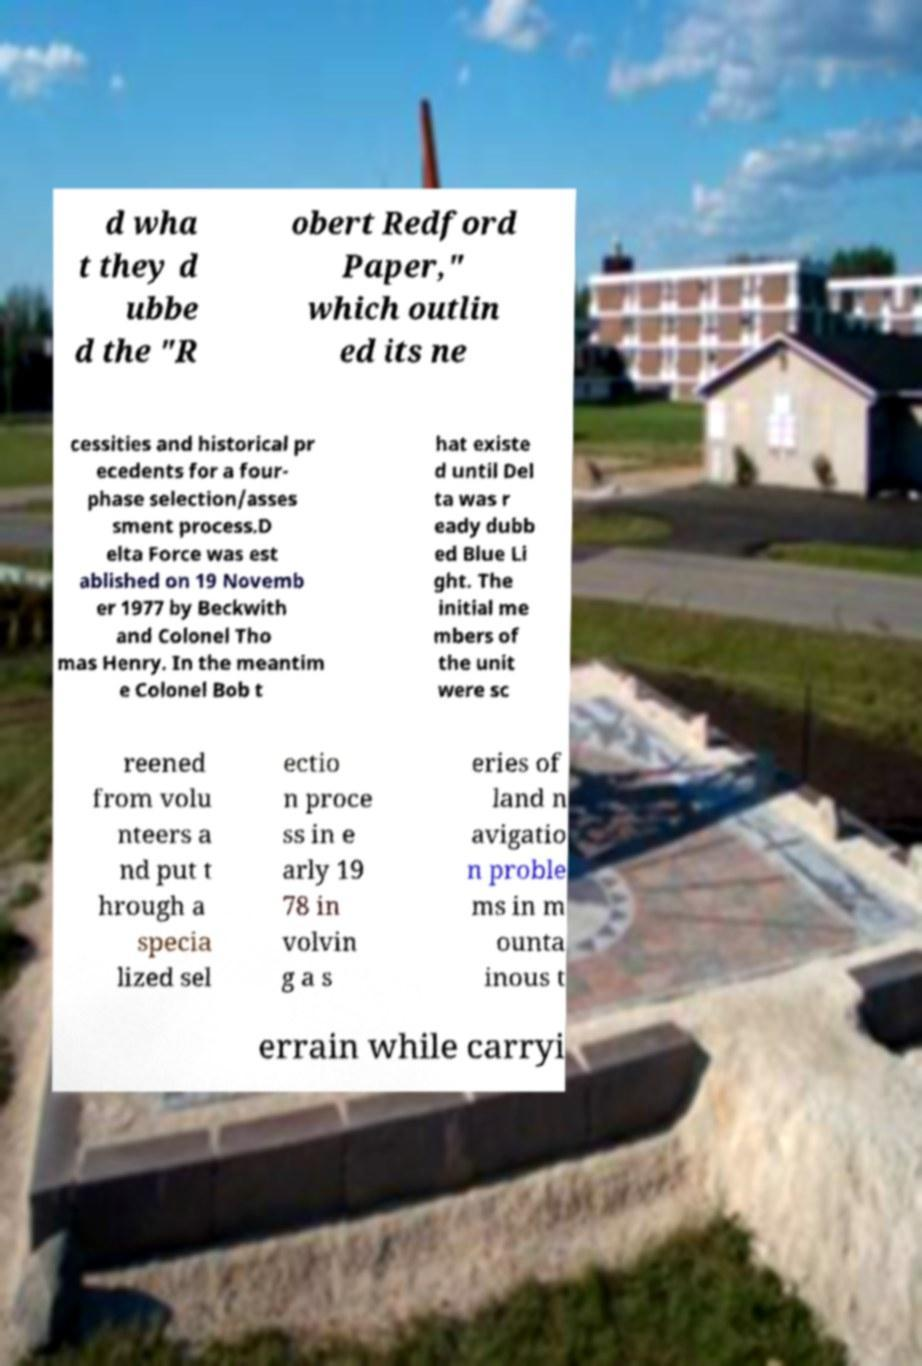Please identify and transcribe the text found in this image. d wha t they d ubbe d the "R obert Redford Paper," which outlin ed its ne cessities and historical pr ecedents for a four- phase selection/asses sment process.D elta Force was est ablished on 19 Novemb er 1977 by Beckwith and Colonel Tho mas Henry. In the meantim e Colonel Bob t hat existe d until Del ta was r eady dubb ed Blue Li ght. The initial me mbers of the unit were sc reened from volu nteers a nd put t hrough a specia lized sel ectio n proce ss in e arly 19 78 in volvin g a s eries of land n avigatio n proble ms in m ounta inous t errain while carryi 